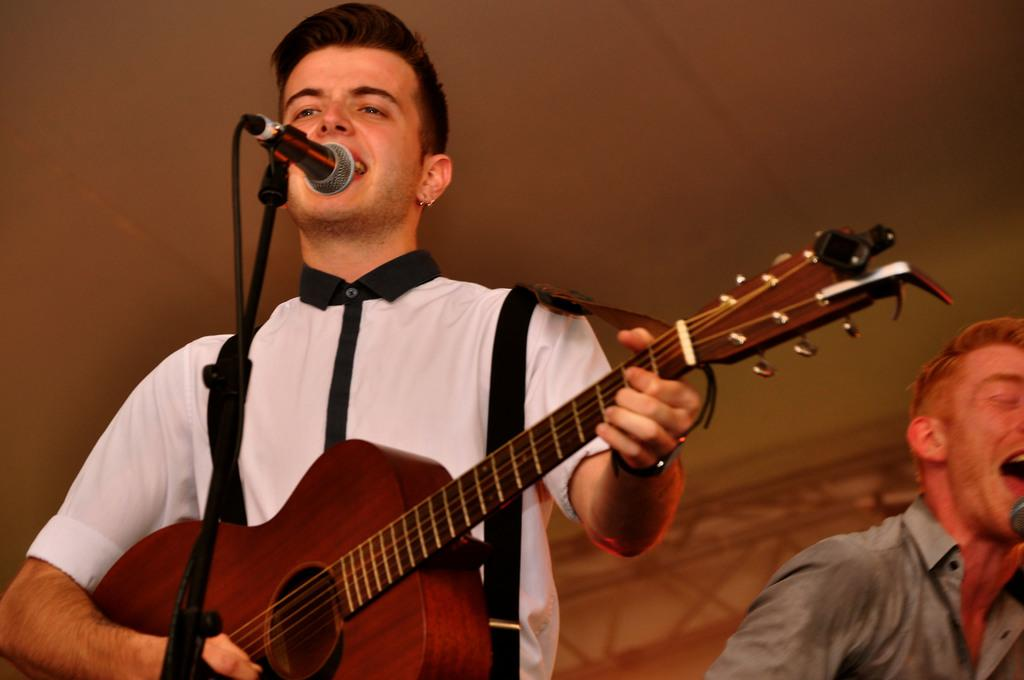How many people are in the image? There are two people in the image. What are the people doing in the image? The people are standing and playing musical instruments. What object is present in the image that is commonly used for amplifying sound? There is a microphone (mic) in the image. What type of support structure is visible in the image? There is a stand in the image. What type of waves can be seen crashing on the shore in the image? There are no waves or shore visible in the image; it features two people playing musical instruments. 